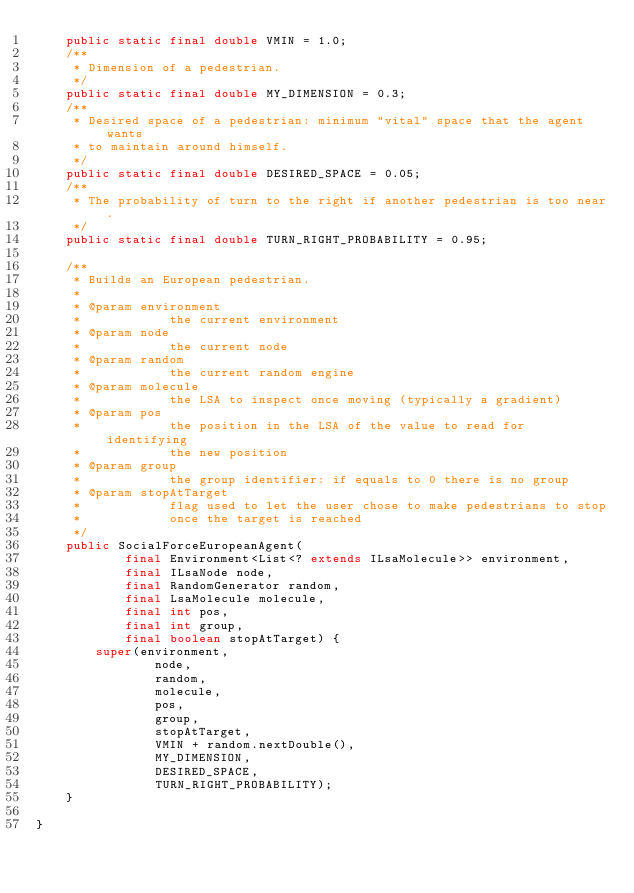Convert code to text. <code><loc_0><loc_0><loc_500><loc_500><_Java_>    public static final double VMIN = 1.0;
    /**
     * Dimension of a pedestrian.
     */
    public static final double MY_DIMENSION = 0.3;
    /**
     * Desired space of a pedestrian: minimum "vital" space that the agent wants
     * to maintain around himself.
     */
    public static final double DESIRED_SPACE = 0.05;
    /**
     * The probability of turn to the right if another pedestrian is too near.
     */
    public static final double TURN_RIGHT_PROBABILITY = 0.95;

    /**
     * Builds an European pedestrian.
     * 
     * @param environment
     *            the current environment
     * @param node
     *            the current node
     * @param random
     *            the current random engine
     * @param molecule
     *            the LSA to inspect once moving (typically a gradient)
     * @param pos
     *            the position in the LSA of the value to read for identifying
     *            the new position
     * @param group
     *            the group identifier: if equals to 0 there is no group
     * @param stopAtTarget
     *            flag used to let the user chose to make pedestrians to stop
     *            once the target is reached
     */
    public SocialForceEuropeanAgent(
            final Environment<List<? extends ILsaMolecule>> environment,
            final ILsaNode node,
            final RandomGenerator random,
            final LsaMolecule molecule,
            final int pos,
            final int group,
            final boolean stopAtTarget) {
        super(environment,
                node,
                random,
                molecule,
                pos,
                group,
                stopAtTarget,
                VMIN + random.nextDouble(),
                MY_DIMENSION,
                DESIRED_SPACE,
                TURN_RIGHT_PROBABILITY);
    }

}
</code> 